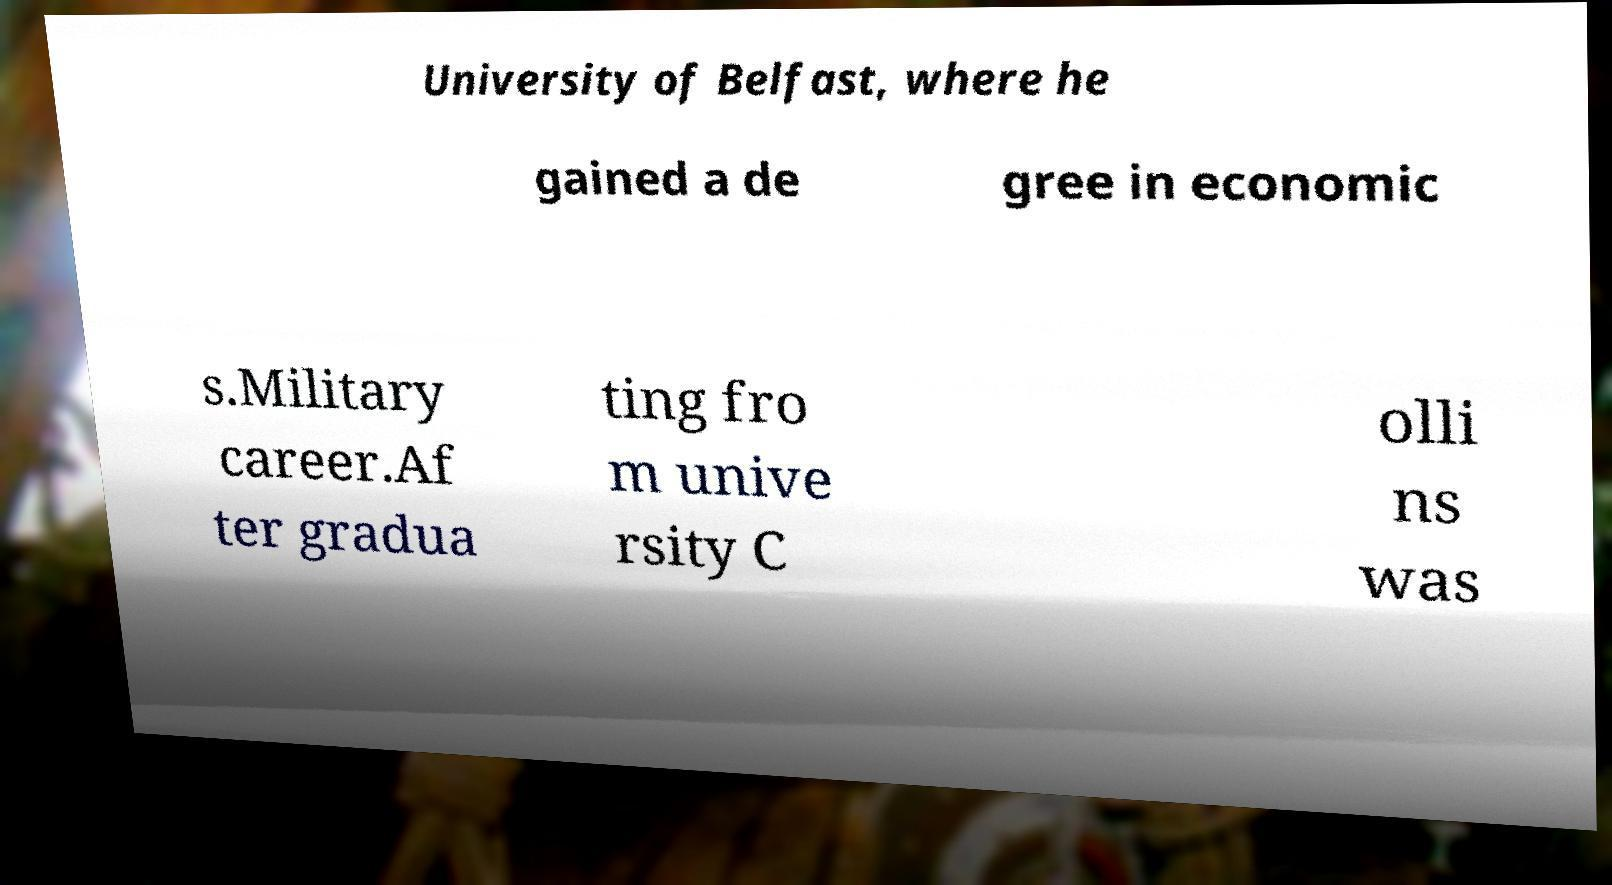I need the written content from this picture converted into text. Can you do that? University of Belfast, where he gained a de gree in economic s.Military career.Af ter gradua ting fro m unive rsity C olli ns was 